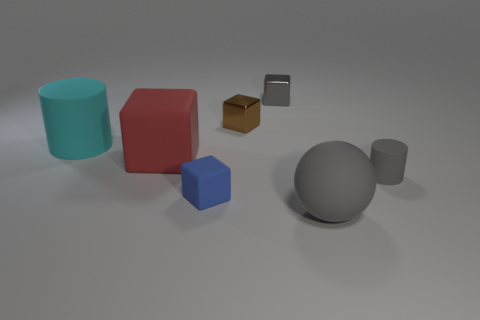There is a gray rubber object that is left of the small rubber cylinder; what size is it?
Provide a succinct answer. Large. There is a big matte cube; is its color the same as the rubber cylinder that is to the right of the tiny brown shiny cube?
Your answer should be very brief. No. Are there any big rubber objects that have the same color as the big cylinder?
Provide a succinct answer. No. Is the big gray object made of the same material as the cube that is in front of the red object?
Offer a terse response. Yes. What number of small objects are gray shiny spheres or cyan matte cylinders?
Offer a very short reply. 0. What is the material of the large object that is the same color as the tiny rubber cylinder?
Your answer should be very brief. Rubber. Is the number of small blue matte things less than the number of small cyan rubber things?
Give a very brief answer. No. There is a rubber block on the right side of the big red object; is it the same size as the gray object right of the ball?
Provide a short and direct response. Yes. What number of cyan objects are small rubber things or big shiny blocks?
Provide a succinct answer. 0. What is the size of the metal block that is the same color as the rubber sphere?
Your response must be concise. Small. 